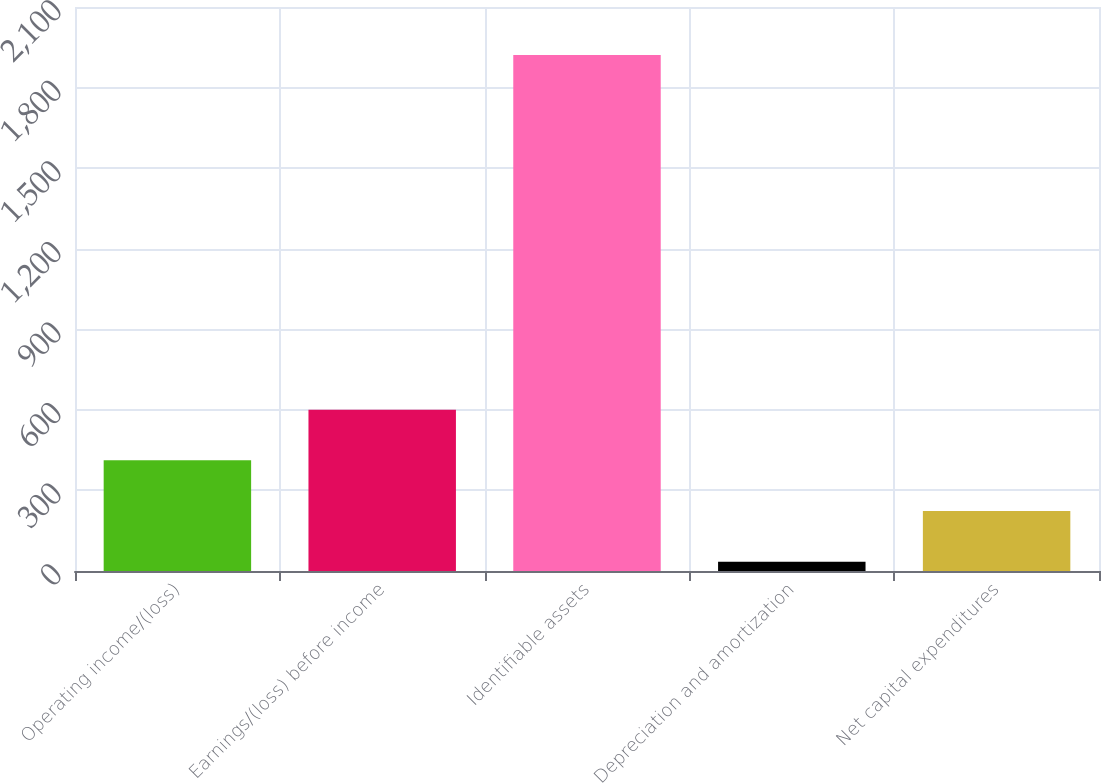Convert chart to OTSL. <chart><loc_0><loc_0><loc_500><loc_500><bar_chart><fcel>Operating income/(loss)<fcel>Earnings/(loss) before income<fcel>Identifiable assets<fcel>Depreciation and amortization<fcel>Net capital expenditures<nl><fcel>411.96<fcel>600.59<fcel>1921<fcel>34.7<fcel>223.33<nl></chart> 